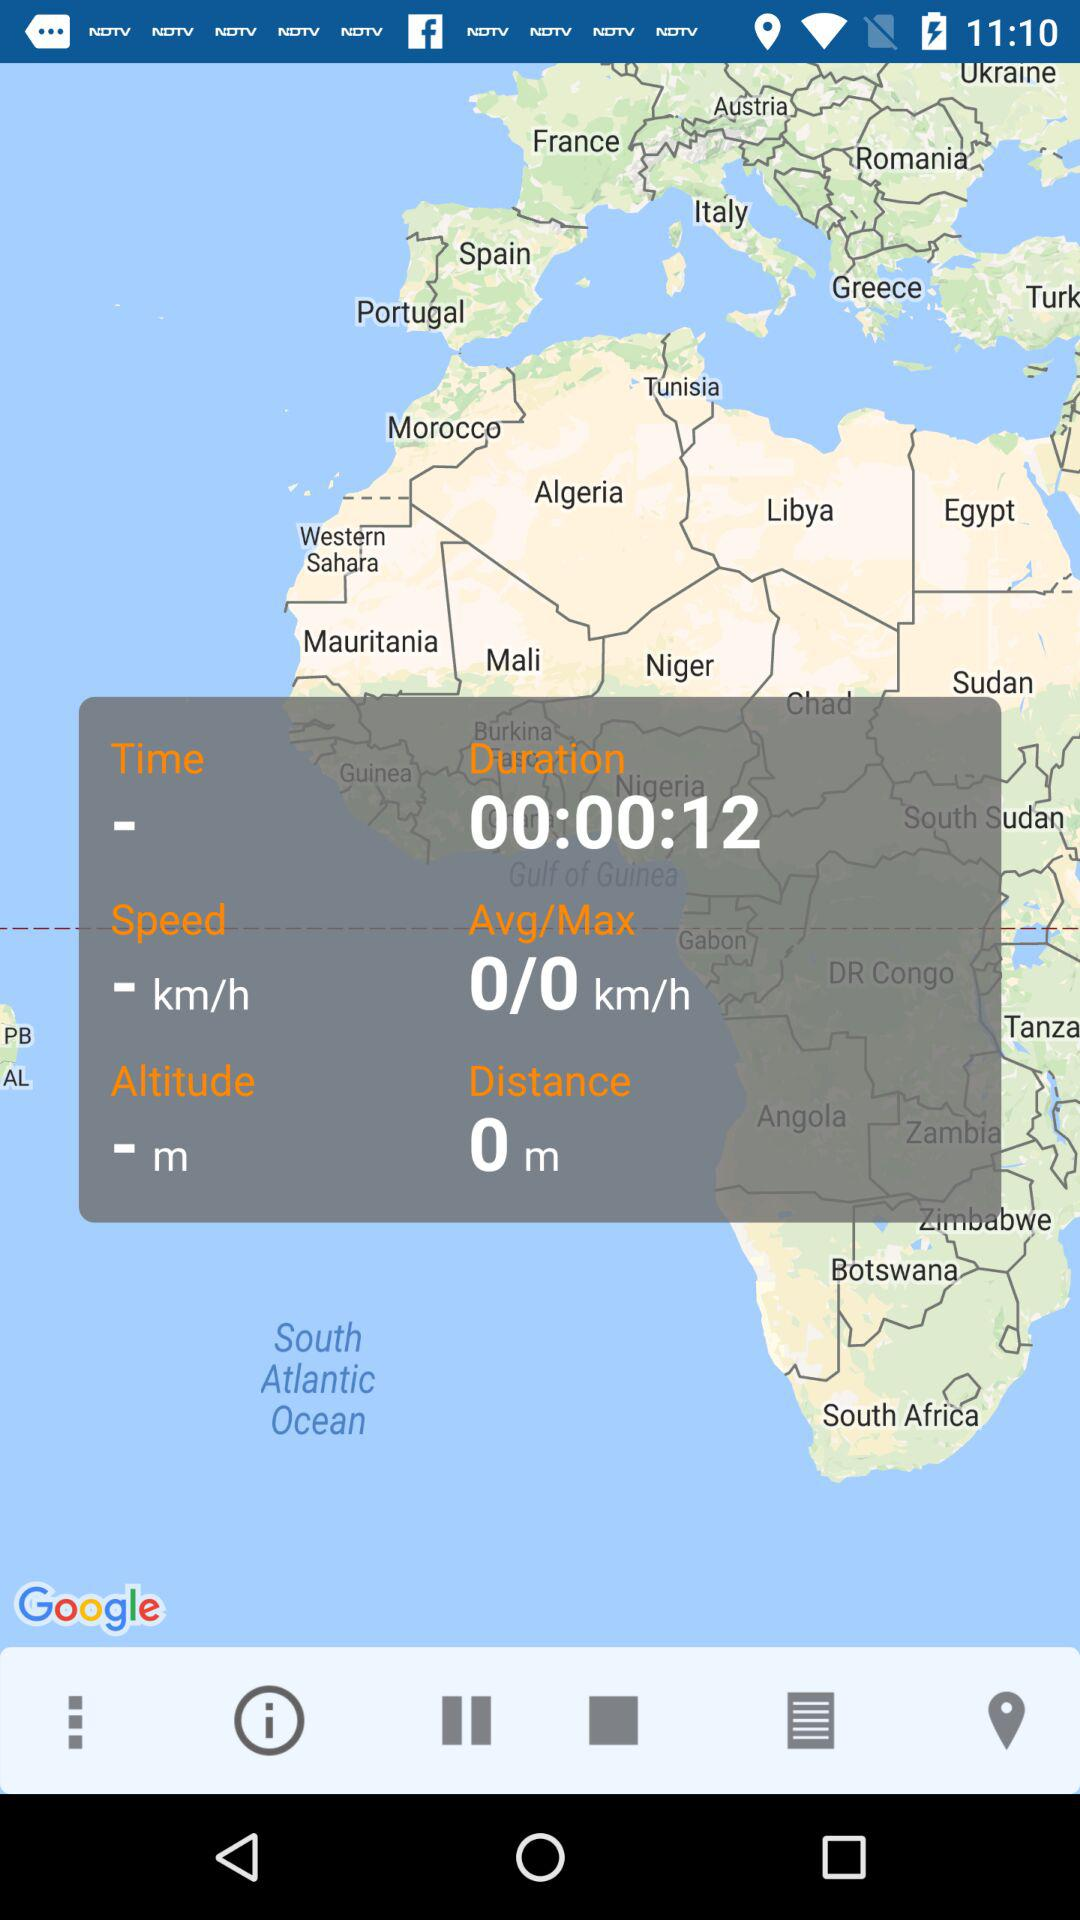What is the average speed? The average speed is 0 km/h. 